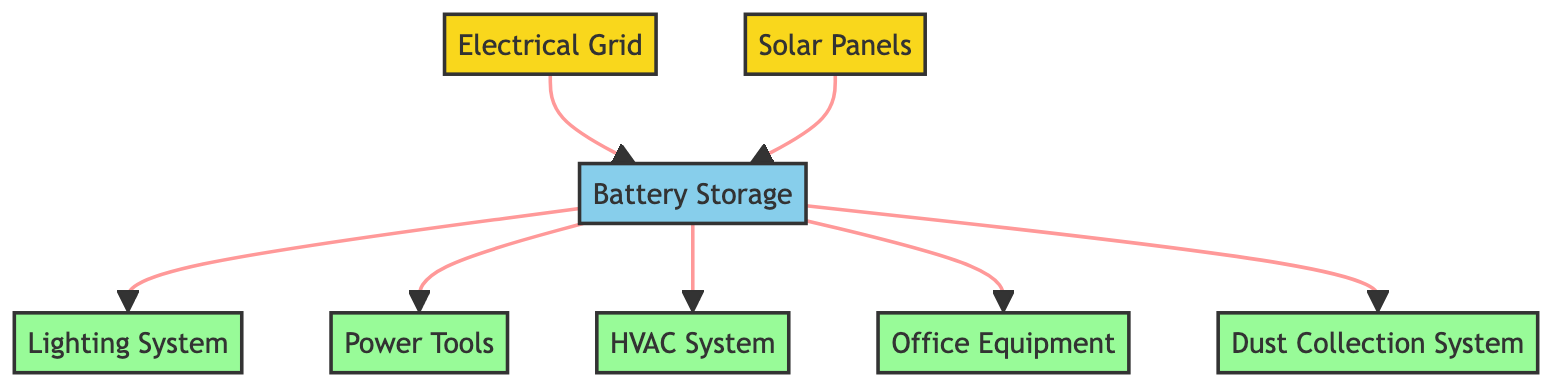What are the sources of energy in the diagram? The diagram lists two sources of energy: the Electrical Grid and Solar Panels. These are the nodes at the bottom that feed into the battery storage.
Answer: Electrical Grid, Solar Panels How many utilities are shown in the diagram? The diagram identifies four utilities: the Lighting System, Power Tools, HVAC System, and Office Equipment, as well as the Dust Collection System, making it a total of five.
Answer: Five What is the purpose of the Battery Storage? The Battery Storage acts as a mechanism to store energy from both the Electrical Grid and Solar Panels for later use by the utilities.
Answer: Store energy Which utility receives energy from the battery? All the utilities—Lighting System, Power Tools, HVAC System, Office Equipment, and Dust Collection System—receive their energy from the Battery Storage.
Answer: All utilities Which source does the Battery receive energy from first? The Battery first receives energy from the Electrical Grid before solar energy is fed into it. In terms of order, it's the Electrical Grid sourced first, followed by the Solar Panels.
Answer: Electrical Grid What is the relationship between the Solar Panels and the Battery Storage? The Solar Panels feed energy directly into the Battery Storage, demonstrating a connection whereby solar energy is stored for future utility usage.
Answer: Feed energy Which utility is most likely powered by the Battery Storage for climate control? The HVAC System is the utility that is most likely powered by the Battery Storage for climate control purposes, as it directly pertains to heating, ventilation, and air conditioning.
Answer: HVAC System How many sources are present in the diagram? The diagram shows two sources: the Electrical Grid and Solar Panels. They both serve to supply energy to the Workshop's Battery Storage.
Answer: Two What kind of storage is represented in the diagram? The diagram represents Battery Storage, which collects and holds energy generated from both the Electrical Grid and the Solar Panels.
Answer: Battery Storage 